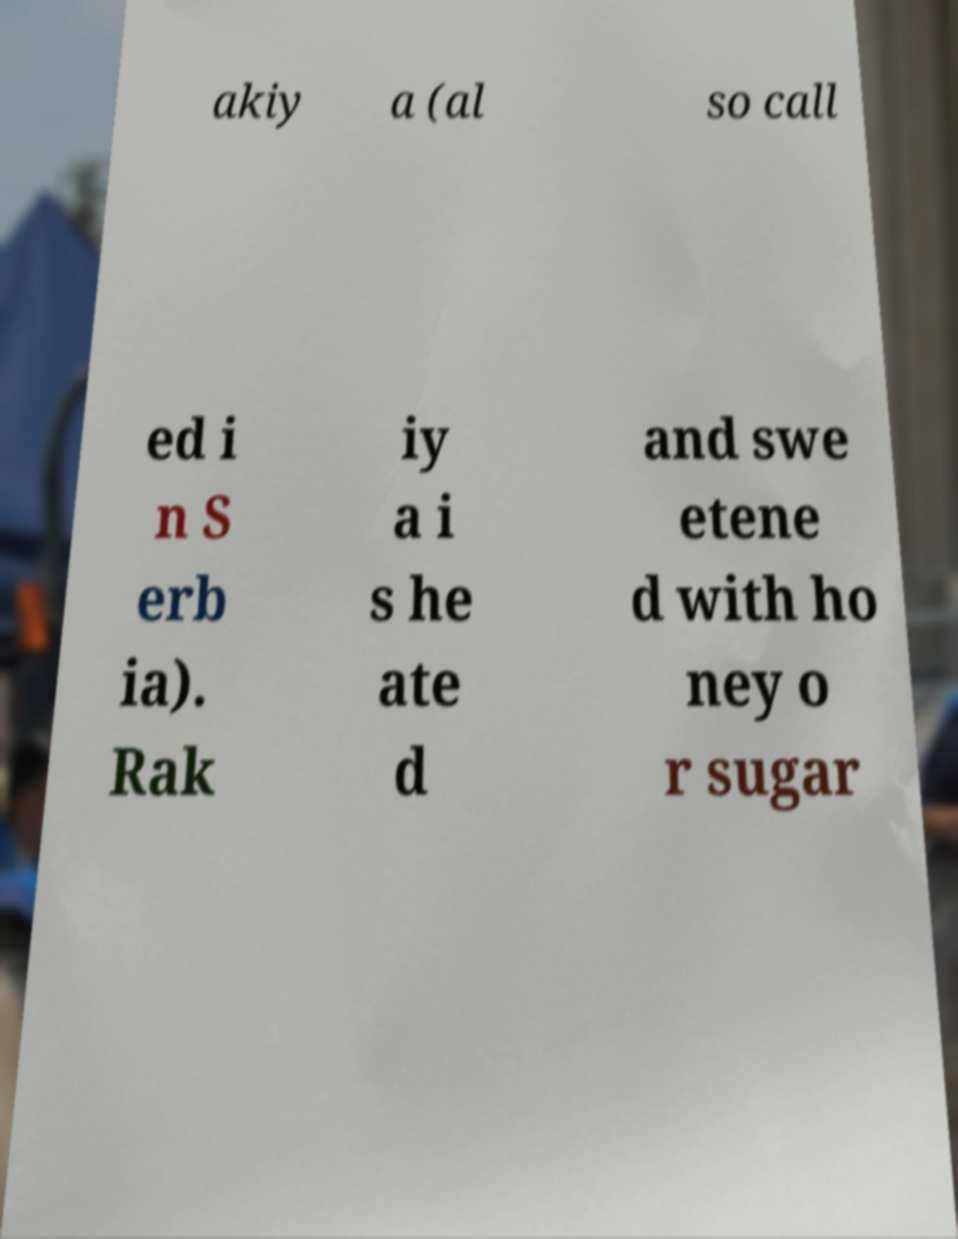Please read and relay the text visible in this image. What does it say? akiy a (al so call ed i n S erb ia). Rak iy a i s he ate d and swe etene d with ho ney o r sugar 